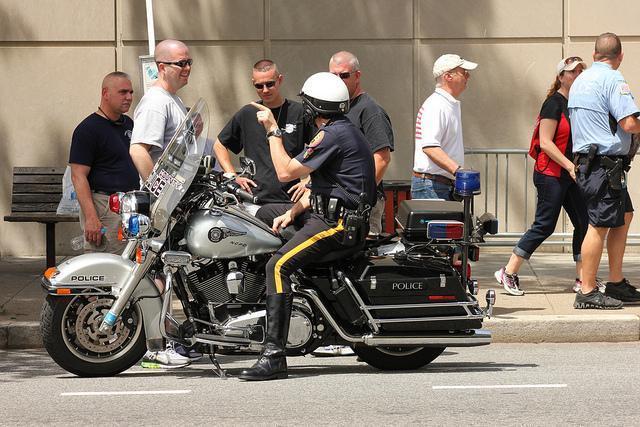How many men are in this picture?
Give a very brief answer. 7. How many people are visible?
Give a very brief answer. 8. 